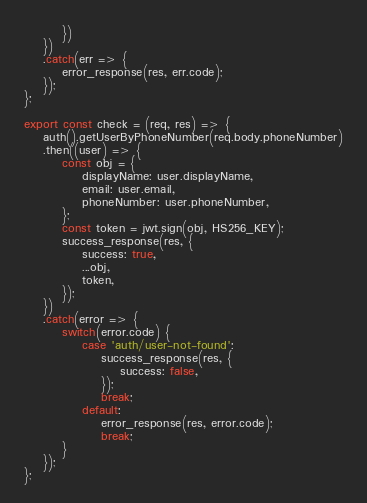<code> <loc_0><loc_0><loc_500><loc_500><_JavaScript_>        })
    })
    .catch(err => {
        error_response(res, err.code);
    });
};

export const check = (req, res) => {
    auth().getUserByPhoneNumber(req.body.phoneNumber)
    .then((user) => {
        const obj = {
            displayName: user.displayName,
            email: user.email,
            phoneNumber: user.phoneNumber,
        };
        const token = jwt.sign(obj, HS256_KEY);
        success_response(res, {
            success: true,
            ...obj,
            token,
        });
    })
    .catch(error => {
        switch(error.code) {
            case 'auth/user-not-found':
                success_response(res, {
                    success: false,
                });
                break;
            default:
                error_response(res, error.code);
                break;
        }
    });
};</code> 